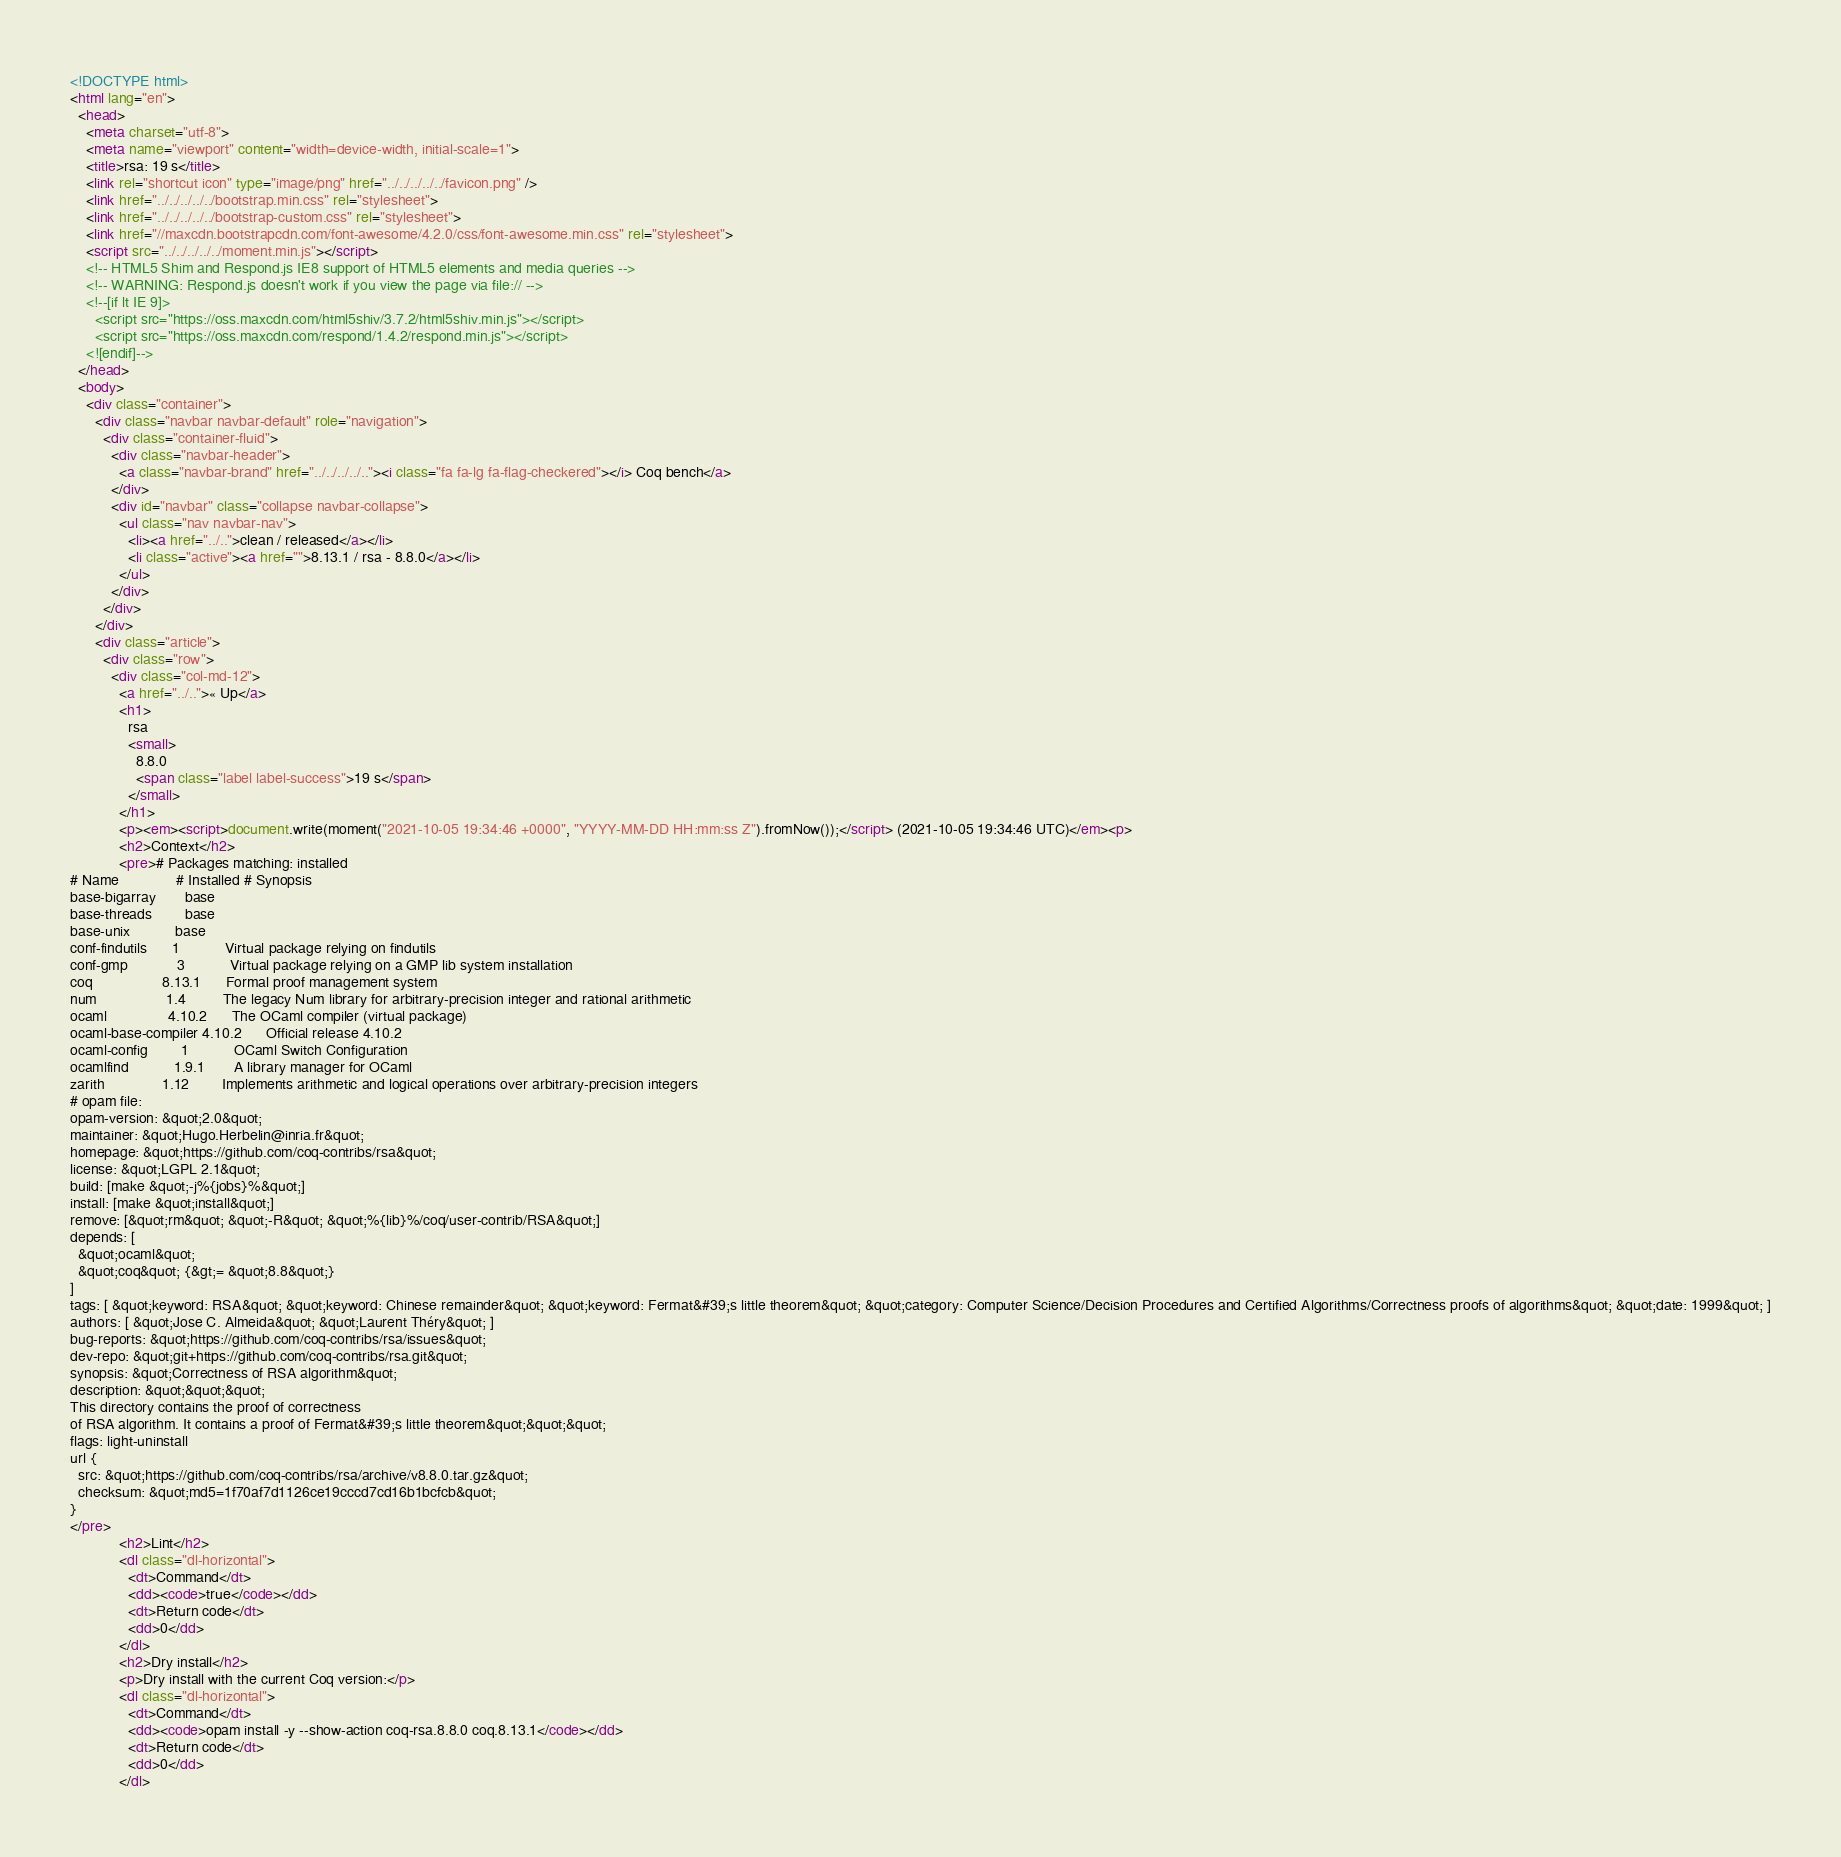<code> <loc_0><loc_0><loc_500><loc_500><_HTML_><!DOCTYPE html>
<html lang="en">
  <head>
    <meta charset="utf-8">
    <meta name="viewport" content="width=device-width, initial-scale=1">
    <title>rsa: 19 s</title>
    <link rel="shortcut icon" type="image/png" href="../../../../../favicon.png" />
    <link href="../../../../../bootstrap.min.css" rel="stylesheet">
    <link href="../../../../../bootstrap-custom.css" rel="stylesheet">
    <link href="//maxcdn.bootstrapcdn.com/font-awesome/4.2.0/css/font-awesome.min.css" rel="stylesheet">
    <script src="../../../../../moment.min.js"></script>
    <!-- HTML5 Shim and Respond.js IE8 support of HTML5 elements and media queries -->
    <!-- WARNING: Respond.js doesn't work if you view the page via file:// -->
    <!--[if lt IE 9]>
      <script src="https://oss.maxcdn.com/html5shiv/3.7.2/html5shiv.min.js"></script>
      <script src="https://oss.maxcdn.com/respond/1.4.2/respond.min.js"></script>
    <![endif]-->
  </head>
  <body>
    <div class="container">
      <div class="navbar navbar-default" role="navigation">
        <div class="container-fluid">
          <div class="navbar-header">
            <a class="navbar-brand" href="../../../../.."><i class="fa fa-lg fa-flag-checkered"></i> Coq bench</a>
          </div>
          <div id="navbar" class="collapse navbar-collapse">
            <ul class="nav navbar-nav">
              <li><a href="../..">clean / released</a></li>
              <li class="active"><a href="">8.13.1 / rsa - 8.8.0</a></li>
            </ul>
          </div>
        </div>
      </div>
      <div class="article">
        <div class="row">
          <div class="col-md-12">
            <a href="../..">« Up</a>
            <h1>
              rsa
              <small>
                8.8.0
                <span class="label label-success">19 s</span>
              </small>
            </h1>
            <p><em><script>document.write(moment("2021-10-05 19:34:46 +0000", "YYYY-MM-DD HH:mm:ss Z").fromNow());</script> (2021-10-05 19:34:46 UTC)</em><p>
            <h2>Context</h2>
            <pre># Packages matching: installed
# Name              # Installed # Synopsis
base-bigarray       base
base-threads        base
base-unix           base
conf-findutils      1           Virtual package relying on findutils
conf-gmp            3           Virtual package relying on a GMP lib system installation
coq                 8.13.1      Formal proof management system
num                 1.4         The legacy Num library for arbitrary-precision integer and rational arithmetic
ocaml               4.10.2      The OCaml compiler (virtual package)
ocaml-base-compiler 4.10.2      Official release 4.10.2
ocaml-config        1           OCaml Switch Configuration
ocamlfind           1.9.1       A library manager for OCaml
zarith              1.12        Implements arithmetic and logical operations over arbitrary-precision integers
# opam file:
opam-version: &quot;2.0&quot;
maintainer: &quot;Hugo.Herbelin@inria.fr&quot;
homepage: &quot;https://github.com/coq-contribs/rsa&quot;
license: &quot;LGPL 2.1&quot;
build: [make &quot;-j%{jobs}%&quot;]
install: [make &quot;install&quot;]
remove: [&quot;rm&quot; &quot;-R&quot; &quot;%{lib}%/coq/user-contrib/RSA&quot;]
depends: [
  &quot;ocaml&quot;
  &quot;coq&quot; {&gt;= &quot;8.8&quot;}
]
tags: [ &quot;keyword: RSA&quot; &quot;keyword: Chinese remainder&quot; &quot;keyword: Fermat&#39;s little theorem&quot; &quot;category: Computer Science/Decision Procedures and Certified Algorithms/Correctness proofs of algorithms&quot; &quot;date: 1999&quot; ]
authors: [ &quot;Jose C. Almeida&quot; &quot;Laurent Théry&quot; ]
bug-reports: &quot;https://github.com/coq-contribs/rsa/issues&quot;
dev-repo: &quot;git+https://github.com/coq-contribs/rsa.git&quot;
synopsis: &quot;Correctness of RSA algorithm&quot;
description: &quot;&quot;&quot;
This directory contains the proof of correctness
of RSA algorithm. It contains a proof of Fermat&#39;s little theorem&quot;&quot;&quot;
flags: light-uninstall
url {
  src: &quot;https://github.com/coq-contribs/rsa/archive/v8.8.0.tar.gz&quot;
  checksum: &quot;md5=1f70af7d1126ce19cccd7cd16b1bcfcb&quot;
}
</pre>
            <h2>Lint</h2>
            <dl class="dl-horizontal">
              <dt>Command</dt>
              <dd><code>true</code></dd>
              <dt>Return code</dt>
              <dd>0</dd>
            </dl>
            <h2>Dry install</h2>
            <p>Dry install with the current Coq version:</p>
            <dl class="dl-horizontal">
              <dt>Command</dt>
              <dd><code>opam install -y --show-action coq-rsa.8.8.0 coq.8.13.1</code></dd>
              <dt>Return code</dt>
              <dd>0</dd>
            </dl></code> 